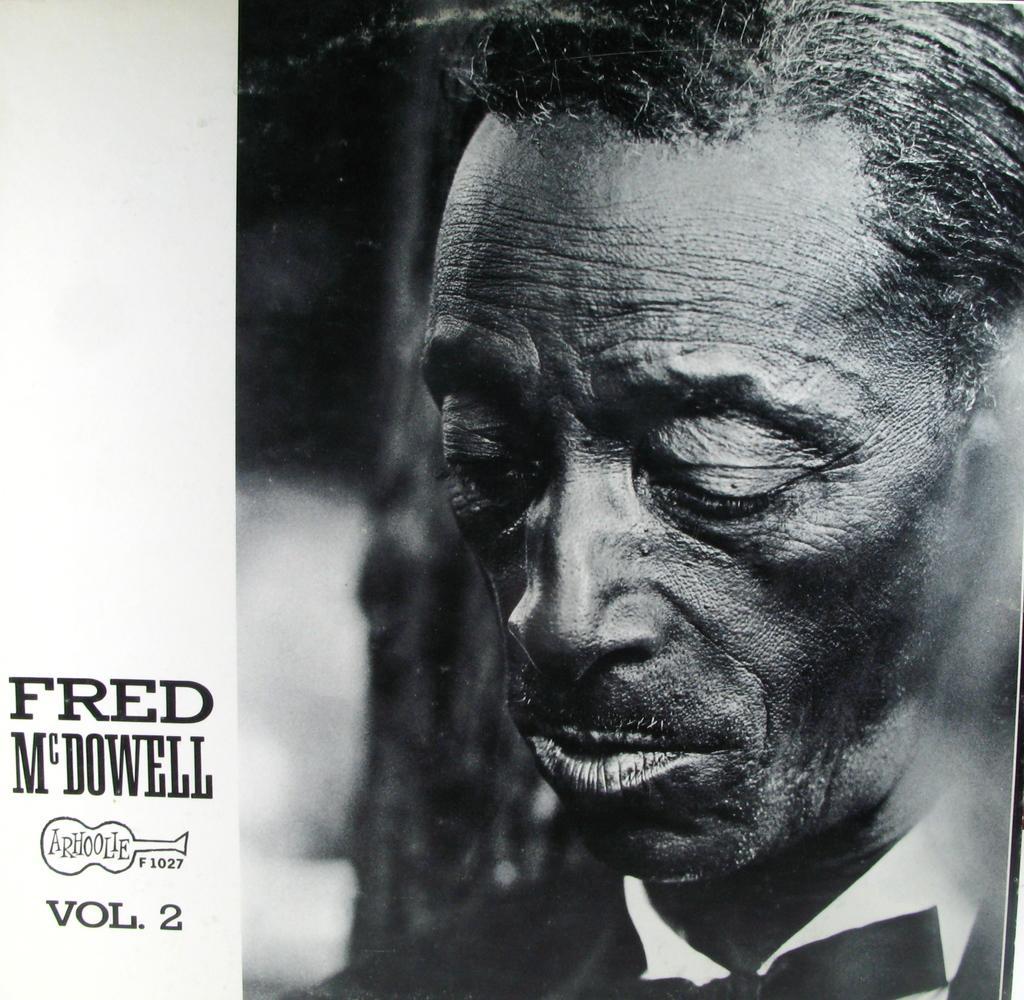Can you describe this image briefly? This is a zoomed in picture. On the right we can see a person. The background of the image is blurry. On the left we can see the text and the numbers on the image. 